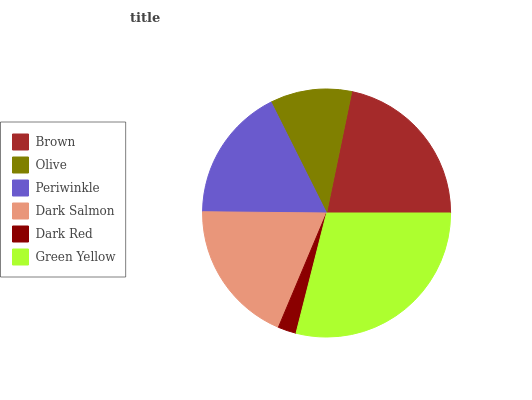Is Dark Red the minimum?
Answer yes or no. Yes. Is Green Yellow the maximum?
Answer yes or no. Yes. Is Olive the minimum?
Answer yes or no. No. Is Olive the maximum?
Answer yes or no. No. Is Brown greater than Olive?
Answer yes or no. Yes. Is Olive less than Brown?
Answer yes or no. Yes. Is Olive greater than Brown?
Answer yes or no. No. Is Brown less than Olive?
Answer yes or no. No. Is Dark Salmon the high median?
Answer yes or no. Yes. Is Periwinkle the low median?
Answer yes or no. Yes. Is Olive the high median?
Answer yes or no. No. Is Olive the low median?
Answer yes or no. No. 